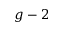<formula> <loc_0><loc_0><loc_500><loc_500>g - 2</formula> 